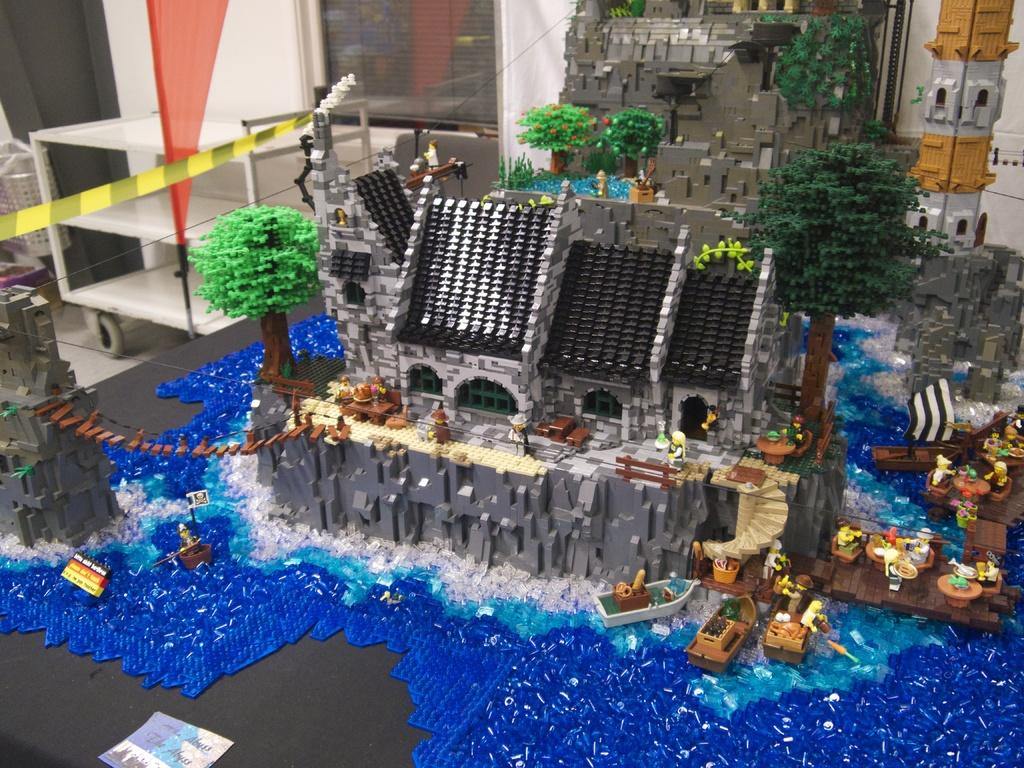What is the main subject of the picture? The main subject of the picture is a scale model of a building. Can you describe the scale model in more detail? The scale model is located in the middle of the picture. What is visible in the background of the picture? There is a wall in the background of the picture. What type of cheese is being used to build the cannon in the image? There is no cheese or cannon present in the image; it features a scale model of a building and a wall in the background. 